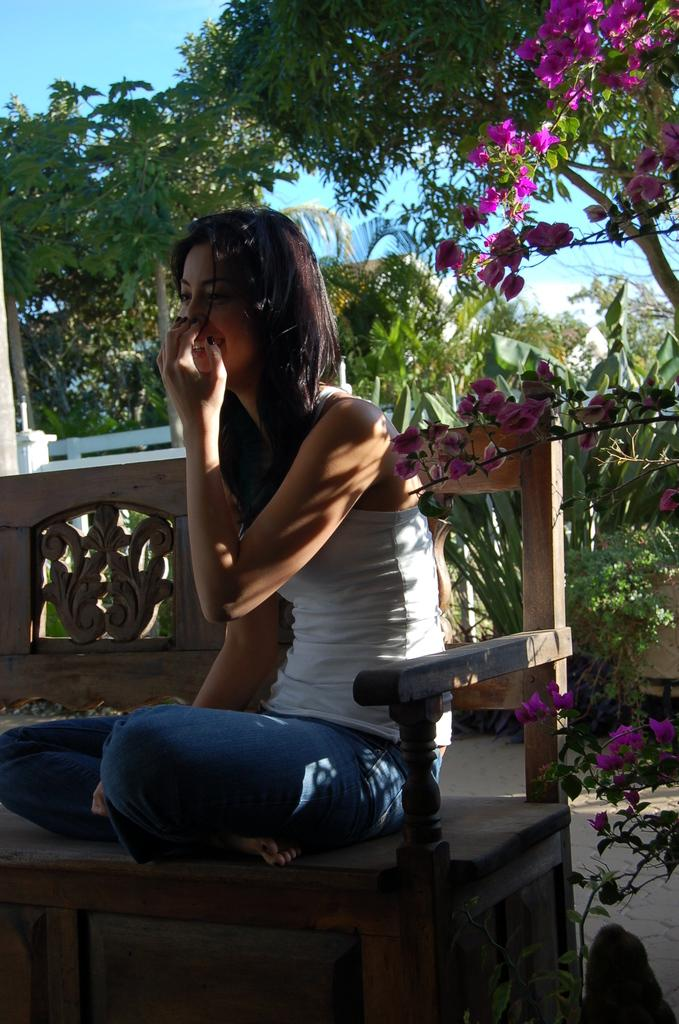Who is the main subject in the image? There is a woman in the image. What is the woman doing in the image? The woman is sitting on a bench. What is the woman's facial expression in the image? The woman is smiling. What is the woman doing with her hand in the image? The woman has her hand on her mouth. What can be seen in the background of the image? There are beautiful trees around the woman. What type of knot is the woman tying in the image? There is no knot present in the image; the woman has her hand on her mouth. What is the woman using to stir the soup in the image? There is no soup or spoon present in the image; the woman is sitting on a bench and smiling. 